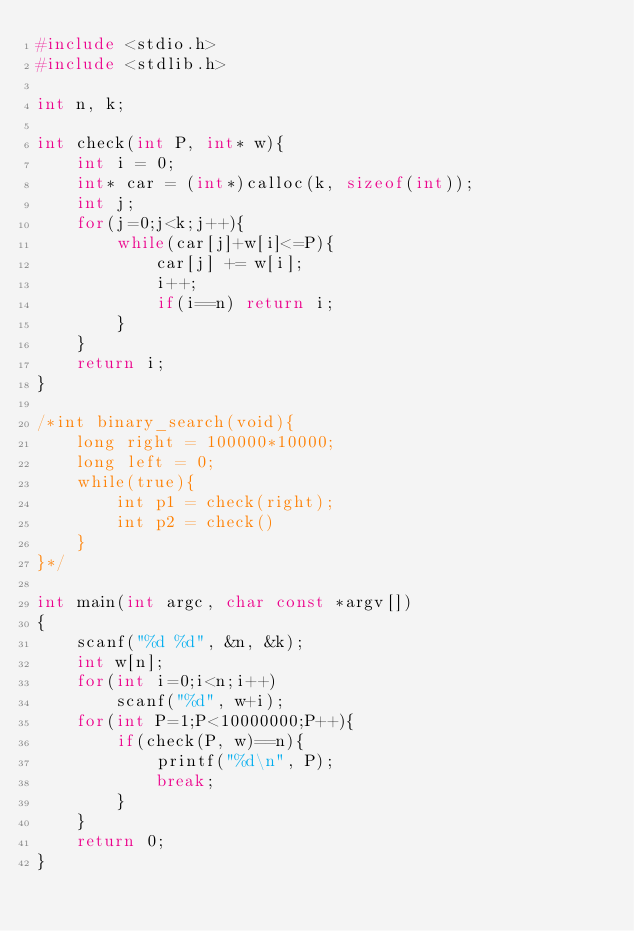<code> <loc_0><loc_0><loc_500><loc_500><_C_>#include <stdio.h>
#include <stdlib.h>

int n, k;

int check(int P, int* w){
	int i = 0;
	int* car = (int*)calloc(k, sizeof(int));
	int j;
	for(j=0;j<k;j++){
		while(car[j]+w[i]<=P){
			car[j] += w[i];
			i++;
			if(i==n) return i;
		}
	}
	return i;
}

/*int binary_search(void){
	long right = 100000*10000;
	long left = 0;
	while(true){
		int p1 = check(right);
		int p2 = check()
	}
}*/

int main(int argc, char const *argv[])
{
	scanf("%d %d", &n, &k);
	int w[n];
	for(int i=0;i<n;i++)
		scanf("%d", w+i);
	for(int P=1;P<10000000;P++){
		if(check(P, w)==n){
			printf("%d\n", P);
			break;
		}
	}
	return 0;
}

</code> 